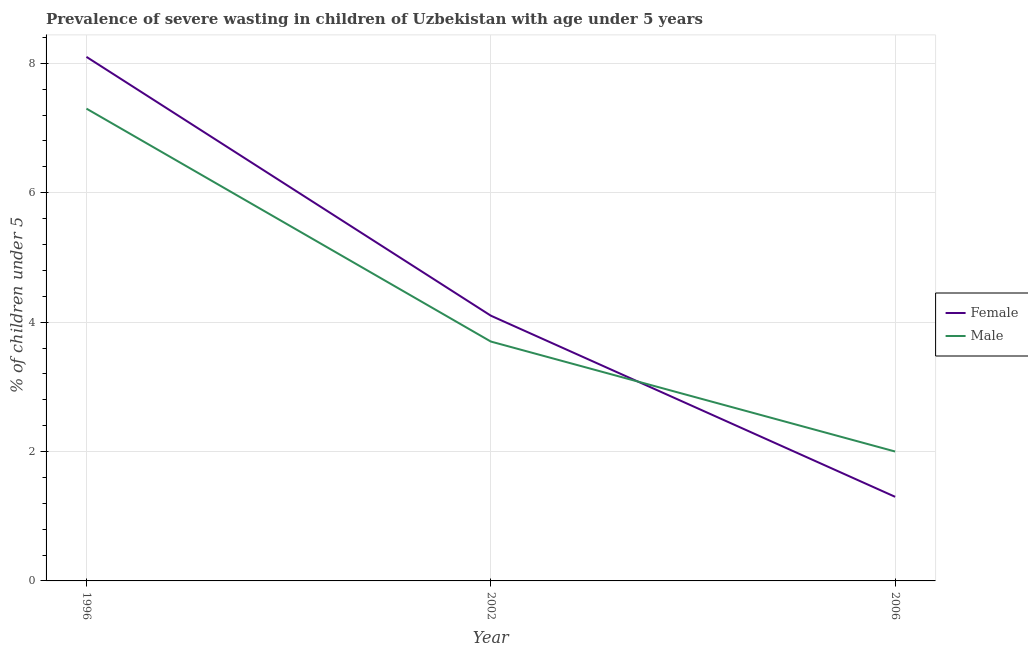What is the percentage of undernourished male children in 2002?
Give a very brief answer. 3.7. Across all years, what is the maximum percentage of undernourished female children?
Ensure brevity in your answer.  8.1. In which year was the percentage of undernourished male children maximum?
Offer a very short reply. 1996. In which year was the percentage of undernourished male children minimum?
Your response must be concise. 2006. What is the total percentage of undernourished female children in the graph?
Give a very brief answer. 13.5. What is the difference between the percentage of undernourished female children in 2002 and that in 2006?
Provide a short and direct response. 2.8. What is the difference between the percentage of undernourished female children in 1996 and the percentage of undernourished male children in 2006?
Your answer should be very brief. 6.1. What is the average percentage of undernourished female children per year?
Your response must be concise. 4.5. In the year 1996, what is the difference between the percentage of undernourished male children and percentage of undernourished female children?
Your answer should be very brief. -0.8. In how many years, is the percentage of undernourished male children greater than 4 %?
Give a very brief answer. 1. What is the ratio of the percentage of undernourished female children in 2002 to that in 2006?
Provide a succinct answer. 3.15. Is the percentage of undernourished female children in 2002 less than that in 2006?
Keep it short and to the point. No. Is the difference between the percentage of undernourished male children in 2002 and 2006 greater than the difference between the percentage of undernourished female children in 2002 and 2006?
Provide a succinct answer. No. What is the difference between the highest and the second highest percentage of undernourished male children?
Give a very brief answer. 3.6. What is the difference between the highest and the lowest percentage of undernourished female children?
Provide a succinct answer. 6.8. In how many years, is the percentage of undernourished male children greater than the average percentage of undernourished male children taken over all years?
Your answer should be very brief. 1. Is the sum of the percentage of undernourished female children in 1996 and 2006 greater than the maximum percentage of undernourished male children across all years?
Offer a terse response. Yes. Is the percentage of undernourished male children strictly greater than the percentage of undernourished female children over the years?
Provide a short and direct response. No. How many years are there in the graph?
Your response must be concise. 3. What is the difference between two consecutive major ticks on the Y-axis?
Provide a succinct answer. 2. Are the values on the major ticks of Y-axis written in scientific E-notation?
Make the answer very short. No. What is the title of the graph?
Provide a succinct answer. Prevalence of severe wasting in children of Uzbekistan with age under 5 years. Does "Lowest 10% of population" appear as one of the legend labels in the graph?
Offer a terse response. No. What is the label or title of the Y-axis?
Offer a very short reply.  % of children under 5. What is the  % of children under 5 in Female in 1996?
Offer a very short reply. 8.1. What is the  % of children under 5 in Male in 1996?
Provide a succinct answer. 7.3. What is the  % of children under 5 of Female in 2002?
Keep it short and to the point. 4.1. What is the  % of children under 5 in Male in 2002?
Offer a very short reply. 3.7. What is the  % of children under 5 in Female in 2006?
Offer a very short reply. 1.3. What is the  % of children under 5 of Male in 2006?
Provide a short and direct response. 2. Across all years, what is the maximum  % of children under 5 in Female?
Your answer should be compact. 8.1. Across all years, what is the maximum  % of children under 5 in Male?
Offer a very short reply. 7.3. Across all years, what is the minimum  % of children under 5 in Female?
Your answer should be very brief. 1.3. Across all years, what is the minimum  % of children under 5 in Male?
Provide a short and direct response. 2. What is the difference between the  % of children under 5 in Male in 1996 and that in 2002?
Provide a short and direct response. 3.6. What is the difference between the  % of children under 5 in Male in 2002 and that in 2006?
Offer a terse response. 1.7. What is the difference between the  % of children under 5 of Female in 1996 and the  % of children under 5 of Male in 2002?
Make the answer very short. 4.4. What is the difference between the  % of children under 5 of Female in 2002 and the  % of children under 5 of Male in 2006?
Keep it short and to the point. 2.1. What is the average  % of children under 5 in Male per year?
Provide a succinct answer. 4.33. In the year 2002, what is the difference between the  % of children under 5 in Female and  % of children under 5 in Male?
Make the answer very short. 0.4. What is the ratio of the  % of children under 5 in Female in 1996 to that in 2002?
Your answer should be compact. 1.98. What is the ratio of the  % of children under 5 of Male in 1996 to that in 2002?
Your answer should be compact. 1.97. What is the ratio of the  % of children under 5 of Female in 1996 to that in 2006?
Offer a terse response. 6.23. What is the ratio of the  % of children under 5 in Male in 1996 to that in 2006?
Provide a succinct answer. 3.65. What is the ratio of the  % of children under 5 of Female in 2002 to that in 2006?
Make the answer very short. 3.15. What is the ratio of the  % of children under 5 of Male in 2002 to that in 2006?
Provide a short and direct response. 1.85. What is the difference between the highest and the second highest  % of children under 5 of Male?
Your response must be concise. 3.6. What is the difference between the highest and the lowest  % of children under 5 in Female?
Offer a very short reply. 6.8. 